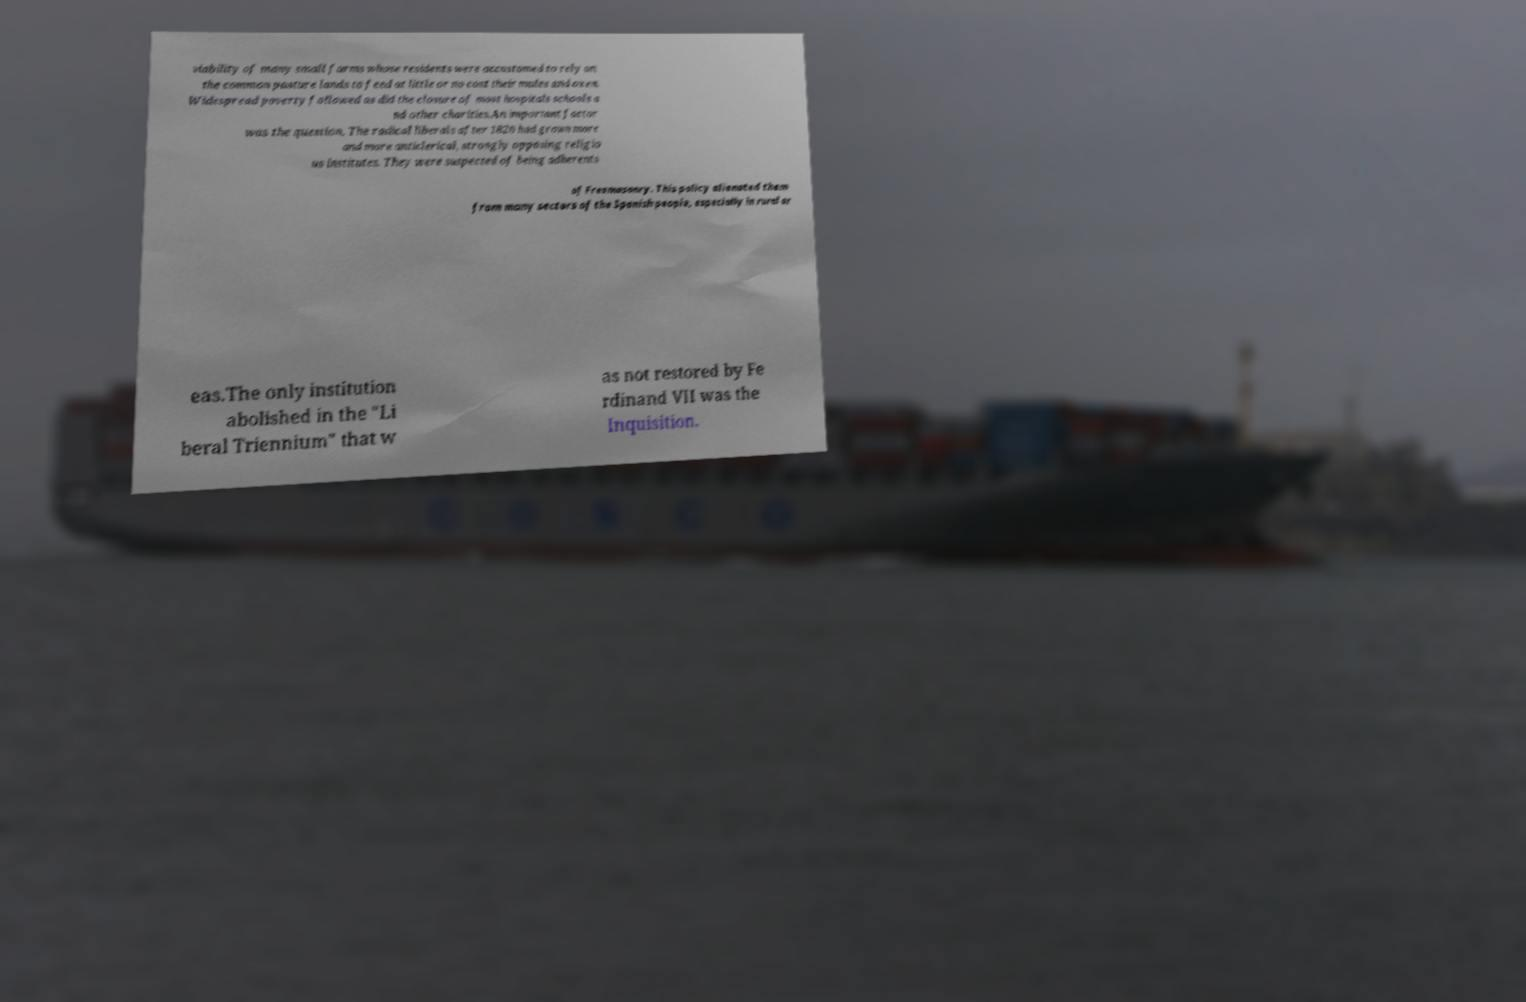Can you read and provide the text displayed in the image?This photo seems to have some interesting text. Can you extract and type it out for me? viability of many small farms whose residents were accustomed to rely on the common pasture lands to feed at little or no cost their mules and oxen. Widespread poverty followed as did the closure of most hospitals schools a nd other charities.An important factor was the question. The radical liberals after 1820 had grown more and more anticlerical, strongly opposing religio us institutes. They were suspected of being adherents of Freemasonry. This policy alienated them from many sectors of the Spanish people, especially in rural ar eas.The only institution abolished in the "Li beral Triennium" that w as not restored by Fe rdinand VII was the Inquisition. 